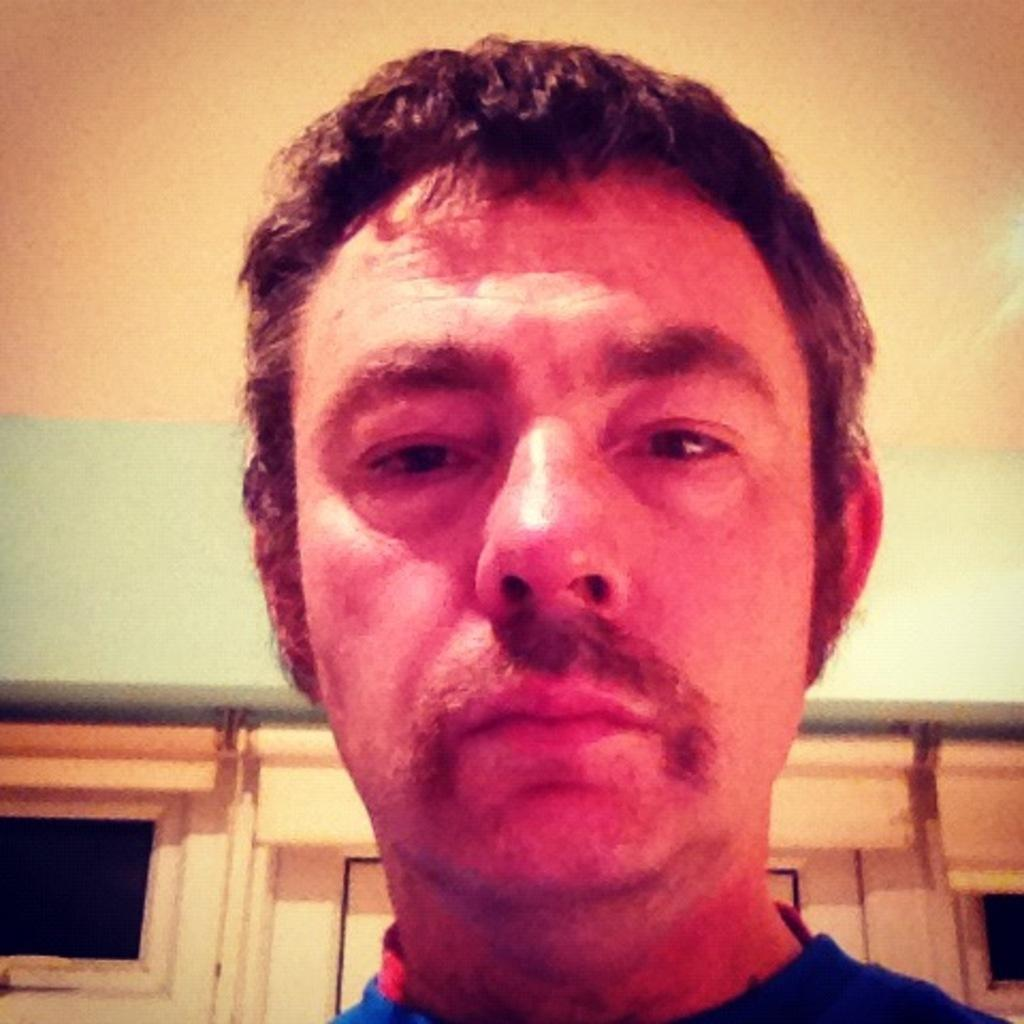Where was the image taken? The image is taken indoors. What can be seen above the scene in the image? There is a ceiling visible in the image. What is visible in the background of the image? There is a wall with windows and a door in the background of the image. Who is the main subject in the image? There is a man in the middle of the image. What type of playground equipment can be seen in the image? There is no playground equipment present in the image. What change might the man be considering in the image? The image does not provide any information about the man's thoughts or intentions, so it is not possible to determine if he is considering any changes. 